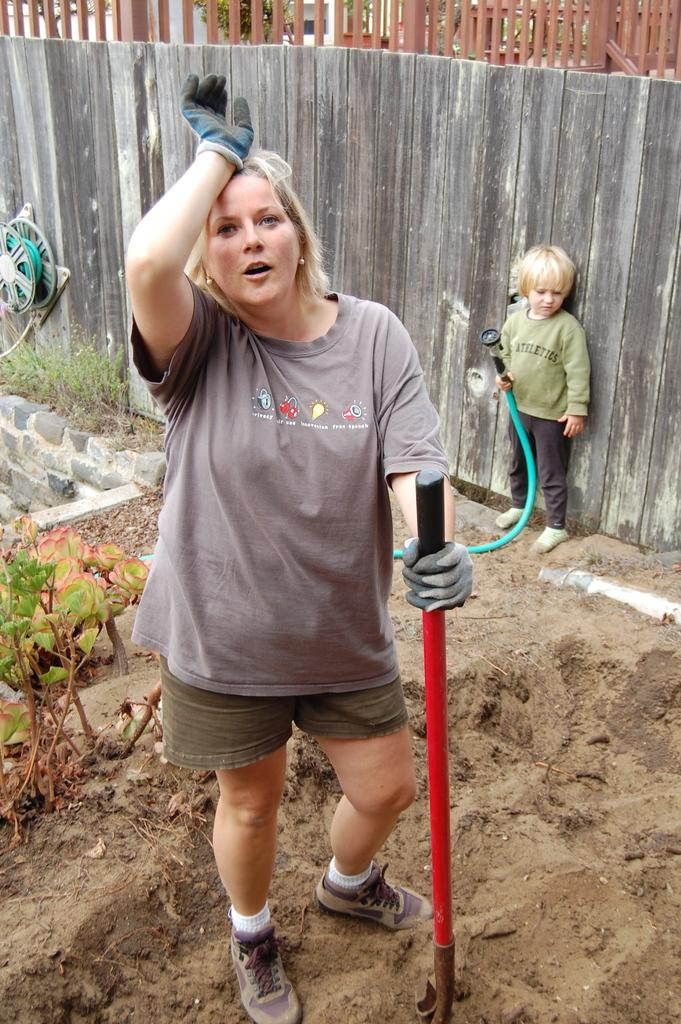What is the main subject of the image? There is a woman in the image. What is the woman holding in the image? The woman is holding a stick. What can be seen in the background of the image? There is a wooden wall, a kid, a grill, a pipe, a plant, and other unspecified things in the background. What type of dress is the woman wearing in the image? The provided facts do not mention the type of dress the woman is wearing. Is there a scarf visible on the woman in the image? There is no mention of a scarf in the provided facts. 